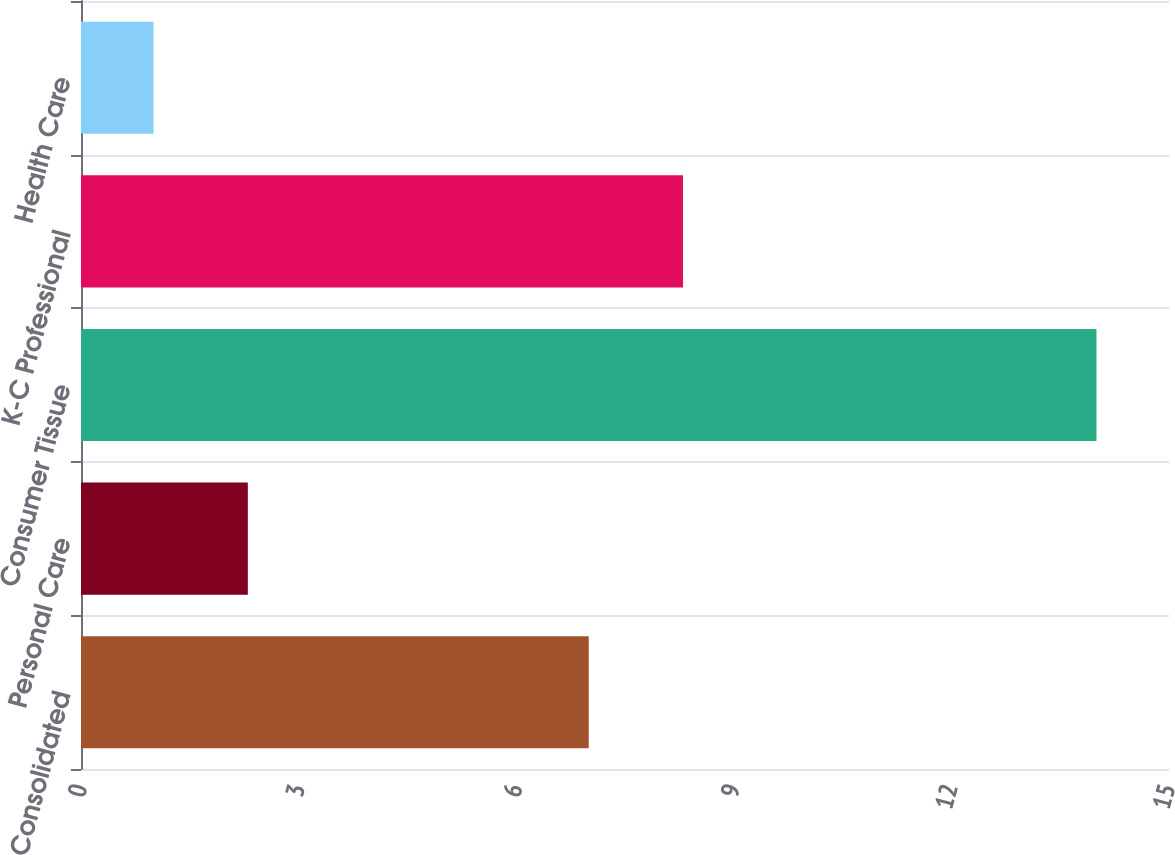<chart> <loc_0><loc_0><loc_500><loc_500><bar_chart><fcel>Consolidated<fcel>Personal Care<fcel>Consumer Tissue<fcel>K-C Professional<fcel>Health Care<nl><fcel>7<fcel>2.3<fcel>14<fcel>8.3<fcel>1<nl></chart> 